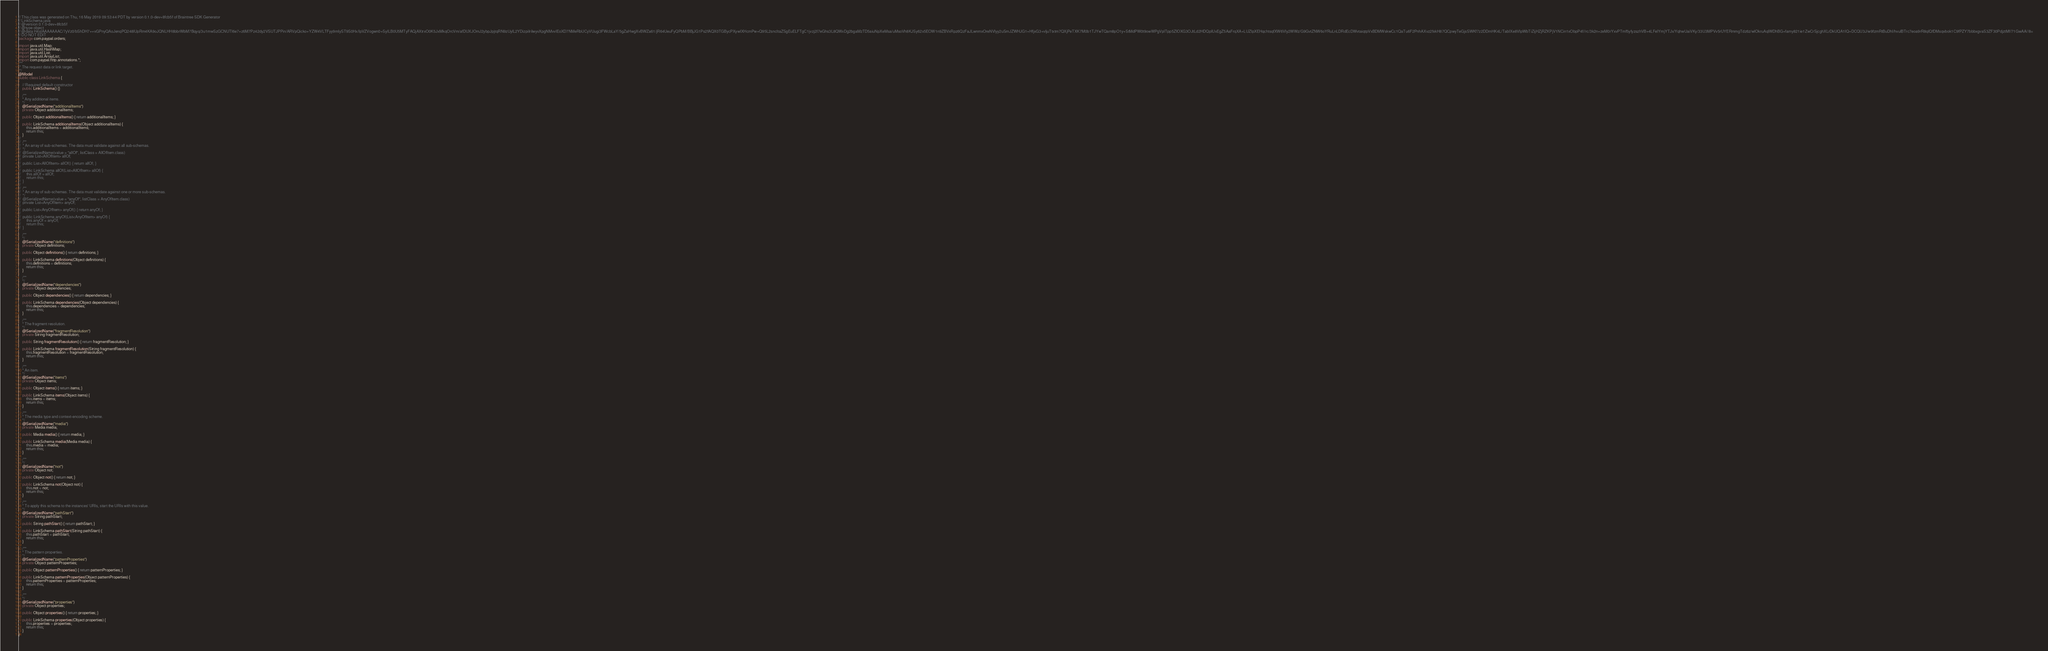<code> <loc_0><loc_0><loc_500><loc_500><_Java_>// This class was generated on Thu, 16 May 2019 09:53:44 PDT by version 0.1.0-dev+8fcb5f of Braintree SDK Generator
// LinkSchema.java
// @version 0.1.0-dev+8fcb5f
// @type object
// @data H4sIAAAAAAAC/7yVz0/bShDH7++vGPnyQAoJenqPQ248lUpRm4KA9oJQNLHH8bbrWbM7Bqyq/3u1mwSzGCNUTI6e7+z6M7Pz42dy2VSUTJPPin/ARVpQicko+YZW4VLTFyy9mIyST9S0Hx/IpVZVogwn0+SyILB0U5MTyFAQjAXtrxO0K5JxMkqOrcVm/afDUXJOmJ2ybpJpjtqRN9zUylL2YDizpiIrilwyvXpgNMvvlEoXD7NMeRbUCyVUugi3FWcbLaY/5gZaHwgXvBWZa61/jR64UeuFyQPbM/BBjJG1Ps2fAQX0TGBycPXywIXHcmPw+Q95L2sncItaZSgEuELFTgC1jvzj2I7eGhs3L8QWxDg2bgaMzTD5aiuNpXeMsa/uMsoVh8KJSy62x5EOW1n9ZBVxRpz6QzFaJLwnmxOreNVlyy2uSmJZWHJG1+HfjxG3+vljuTtxtm7QXjPeTXK7M0b1TJYwTQam8pO1y+StMdPW0t9owWPgVplTpp5ZIOXG3OJtLd2HDQpIUxEgZ5AaFrqXA+LUZIpXEHqchtsqfXW6VIy2WWz/G9GvtZNW6oYRuLnLDRdEcDWvtaiqtpVxBDMWskwCc1QaTu6F2PnhAXvz2fxkH87QCpwyTeGjsSWKf7z2DDmHK4L/TabIXe8VIpWbTiZijHZjRZKPjV1NCin1xObpP4f//rc/3k2n+zeM0rYxvPTmf5yfyzszhVB+4LFelYmjYTJx/YqhwUaiVKy/33U3MPVv5rUYERmmgTdz6z/wlOkruAqlWDhBG+famy821ie1ZwCrSjcghXLrDkUQA1IQ+DCQU3J/w9fzmRtBuDhI/hvulBTrc7eoa9rR8qlQfDMsqvbok1C9fPZY7bbbxgvaS3ZF30PdjztMf/71GwAA//8=
// DO NOT EDIT
package com.paypal.orders;

import java.util.Map;
import java.util.HashMap;
import java.util.List;
import java.util.ArrayList;
import com.paypal.http.annotations.*;
/**
 * The request data or link target.
 */
@Model
public class LinkSchema {

    // Required default constructor
    public LinkSchema() {}

	/**
	* Any additional items.
	*/
	@SerializedName("additionalItems")
	private Object additionalItems;

	public Object additionalItems() { return additionalItems; }

	public LinkSchema additionalItems(Object additionalItems) {
	    this.additionalItems = additionalItems;
	    return this;
	}
//
//	/**
//	* An array of sub-schemas. The data must validate against all sub-schemas.
//	*/
//	@SerializedName(value = "allOf", listClass = AllOfItem.class)
//	private List<AllOfItem> allOf;
//
//	public List<AllOfItem> allOf() { return allOf; }
//
//	public LinkSchema allOf(List<AllOfItem> allOf) {
//	    this.allOf = allOf;
//	    return this;
//	}
//
//	/**
//	* An array of sub-schemas. The data must validate against one or more sub-schemas.
//	*/
//	@SerializedName(value = "anyOf", listClass = AnyOfItem.class)
//	private List<AnyOfItem> anyOf;
//
//	public List<AnyOfItem> anyOf() { return anyOf; }
//
//	public LinkSchema anyOf(List<AnyOfItem> anyOf) {
//	    this.anyOf = anyOf;
//	    return this;
//	}

	/**
	*/
	@SerializedName("definitions")
	private Object definitions;

	public Object definitions() { return definitions; }

	public LinkSchema definitions(Object definitions) {
	    this.definitions = definitions;
	    return this;
	}

	/**
	*/
	@SerializedName("dependencies")
	private Object dependencies;

	public Object dependencies() { return dependencies; }

	public LinkSchema dependencies(Object dependencies) {
	    this.dependencies = dependencies;
	    return this;
	}

	/**
	* The fragment resolution.
	*/
	@SerializedName("fragmentResolution")
	private String fragmentResolution;

	public String fragmentResolution() { return fragmentResolution; }

	public LinkSchema fragmentResolution(String fragmentResolution) {
	    this.fragmentResolution = fragmentResolution;
	    return this;
	}

	/**
	* An item.
	*/
	@SerializedName("items")
	private Object items;

	public Object items() { return items; }

	public LinkSchema items(Object items) {
	    this.items = items;
	    return this;
	}

	/**
	* The media type and context-encoding scheme.
	*/
	@SerializedName("media")
	private Media media;

	public Media media() { return media; }

	public LinkSchema media(Media media) {
	    this.media = media;
	    return this;
	}

	/**
	*/
	@SerializedName("not")
	private Object not;

	public Object not() { return not; }

	public LinkSchema not(Object not) {
	    this.not = not;
	    return this;
	}

	/**
	* To apply this schema to the instances' URIs, start the URIs with this value.
	*/
	@SerializedName("pathStart")
	private String pathStart;

	public String pathStart() { return pathStart; }

	public LinkSchema pathStart(String pathStart) {
	    this.pathStart = pathStart;
	    return this;
	}

	/**
	* The pattern properties.
	*/
	@SerializedName("patternProperties")
	private Object patternProperties;

	public Object patternProperties() { return patternProperties; }

	public LinkSchema patternProperties(Object patternProperties) {
	    this.patternProperties = patternProperties;
	    return this;
	}

	/**
	*/
	@SerializedName("properties")
	private Object properties;

	public Object properties() { return properties; }

	public LinkSchema properties(Object properties) {
	    this.properties = properties;
	    return this;
	}
}
</code> 